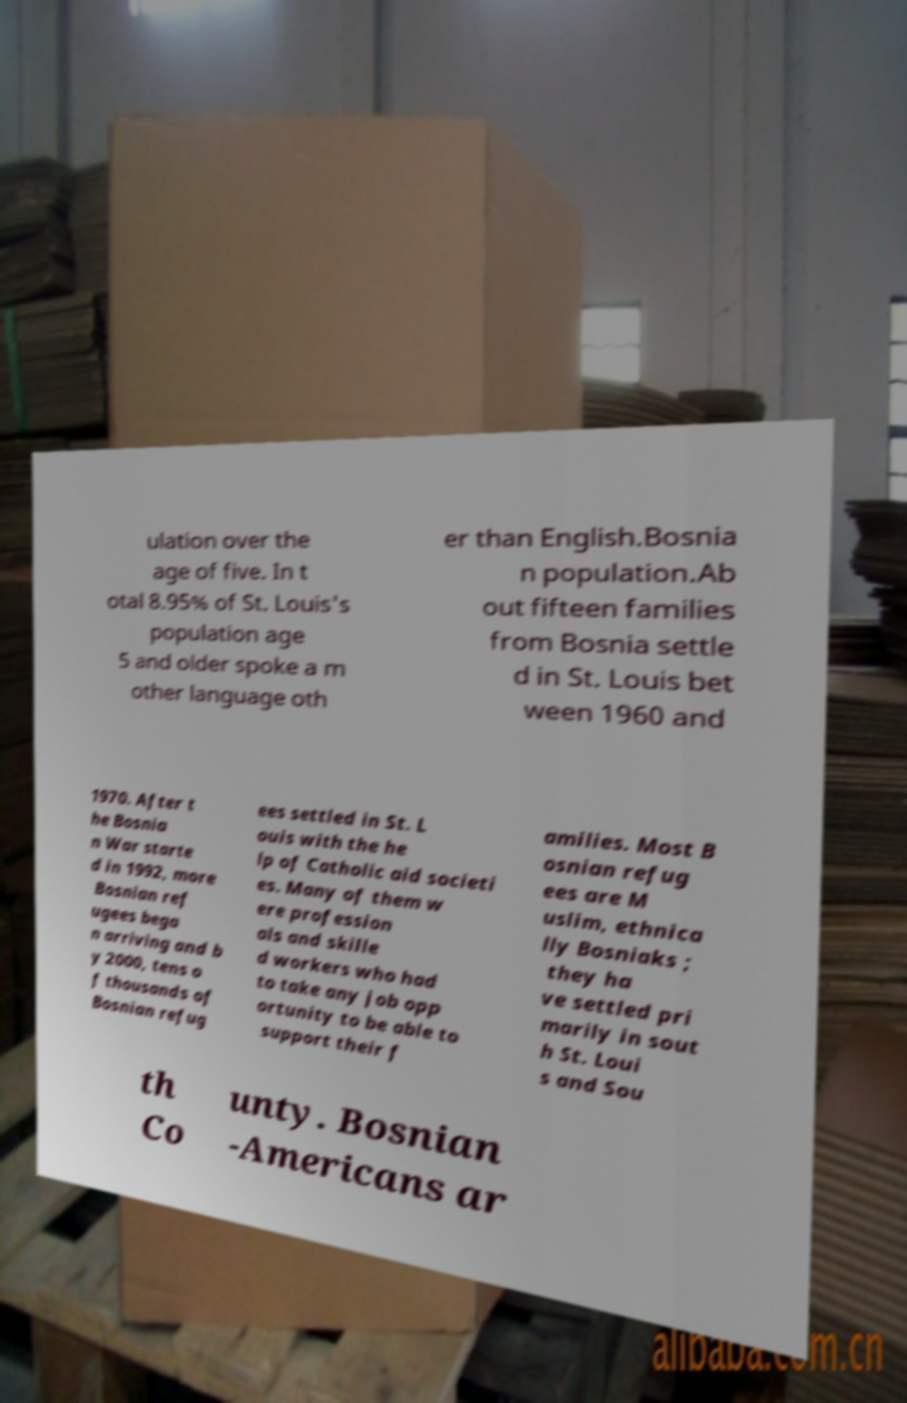What messages or text are displayed in this image? I need them in a readable, typed format. ulation over the age of five. In t otal 8.95% of St. Louis's population age 5 and older spoke a m other language oth er than English.Bosnia n population.Ab out fifteen families from Bosnia settle d in St. Louis bet ween 1960 and 1970. After t he Bosnia n War starte d in 1992, more Bosnian ref ugees bega n arriving and b y 2000, tens o f thousands of Bosnian refug ees settled in St. L ouis with the he lp of Catholic aid societi es. Many of them w ere profession als and skille d workers who had to take any job opp ortunity to be able to support their f amilies. Most B osnian refug ees are M uslim, ethnica lly Bosniaks ; they ha ve settled pri marily in sout h St. Loui s and Sou th Co unty. Bosnian -Americans ar 